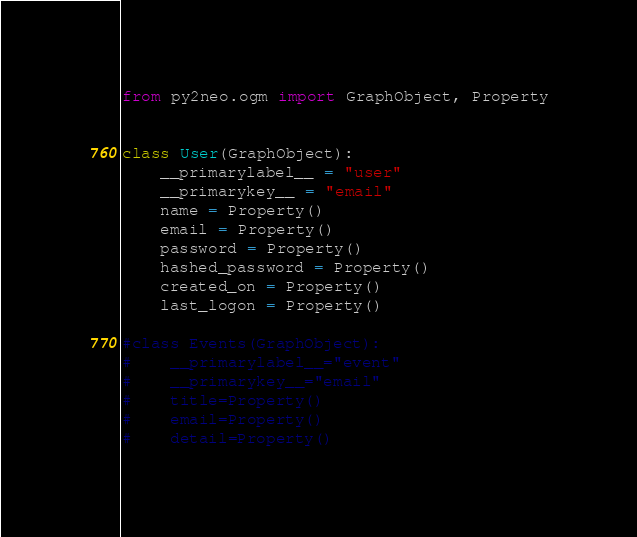Convert code to text. <code><loc_0><loc_0><loc_500><loc_500><_Python_>from py2neo.ogm import GraphObject, Property


class User(GraphObject):
    __primarylabel__ = "user"
    __primarykey__ = "email"
    name = Property()
    email = Property()
    password = Property()
    hashed_password = Property()
    created_on = Property()
    last_logon = Property()

#class Events(GraphObject):
#    __primarylabel__="event"
#    __primarykey__="email"
#    title=Property()
#    email=Property()
#    detail=Property()




</code> 